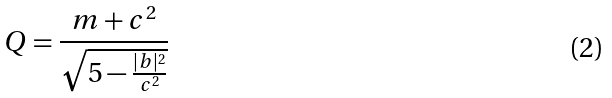<formula> <loc_0><loc_0><loc_500><loc_500>Q = \frac { m + c ^ { 2 } } { \sqrt { 5 - \frac { | b | ^ { 2 } } { c ^ { 2 } } } }</formula> 